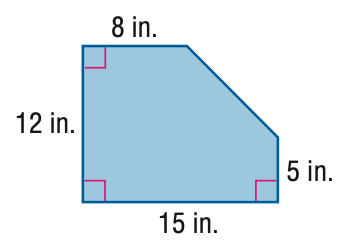Answer the mathemtical geometry problem and directly provide the correct option letter.
Question: Find the area of the figure. Round to the nearest tenth if necessary.
Choices: A: 24.5 B: 49 C: 155.5 D: 180 C 